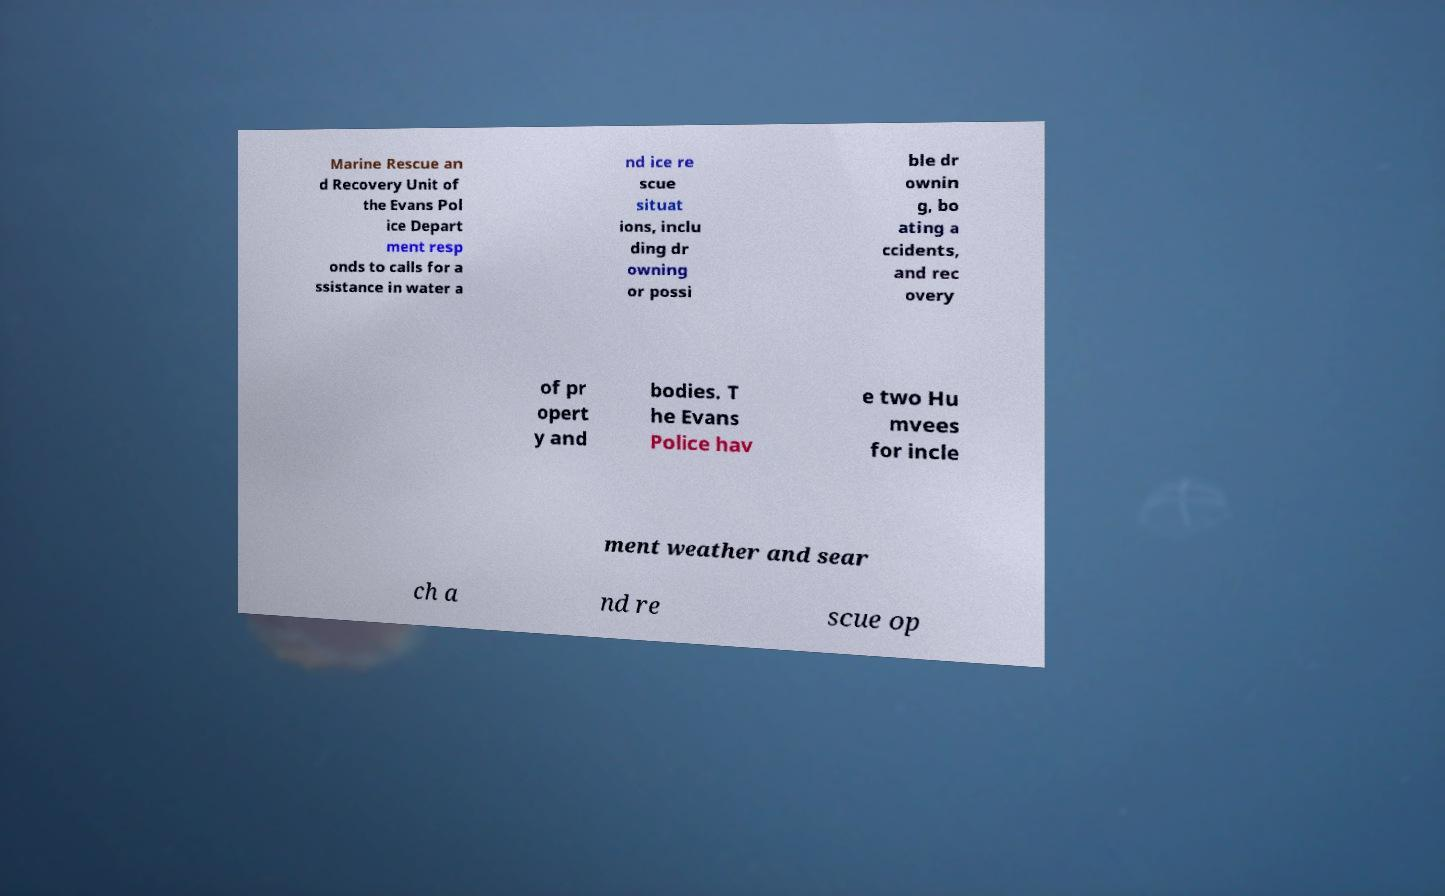Can you read and provide the text displayed in the image?This photo seems to have some interesting text. Can you extract and type it out for me? Marine Rescue an d Recovery Unit of the Evans Pol ice Depart ment resp onds to calls for a ssistance in water a nd ice re scue situat ions, inclu ding dr owning or possi ble dr ownin g, bo ating a ccidents, and rec overy of pr opert y and bodies. T he Evans Police hav e two Hu mvees for incle ment weather and sear ch a nd re scue op 